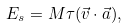<formula> <loc_0><loc_0><loc_500><loc_500>E _ { s } = M \tau ( \vec { v } \cdot \vec { a } ) ,</formula> 